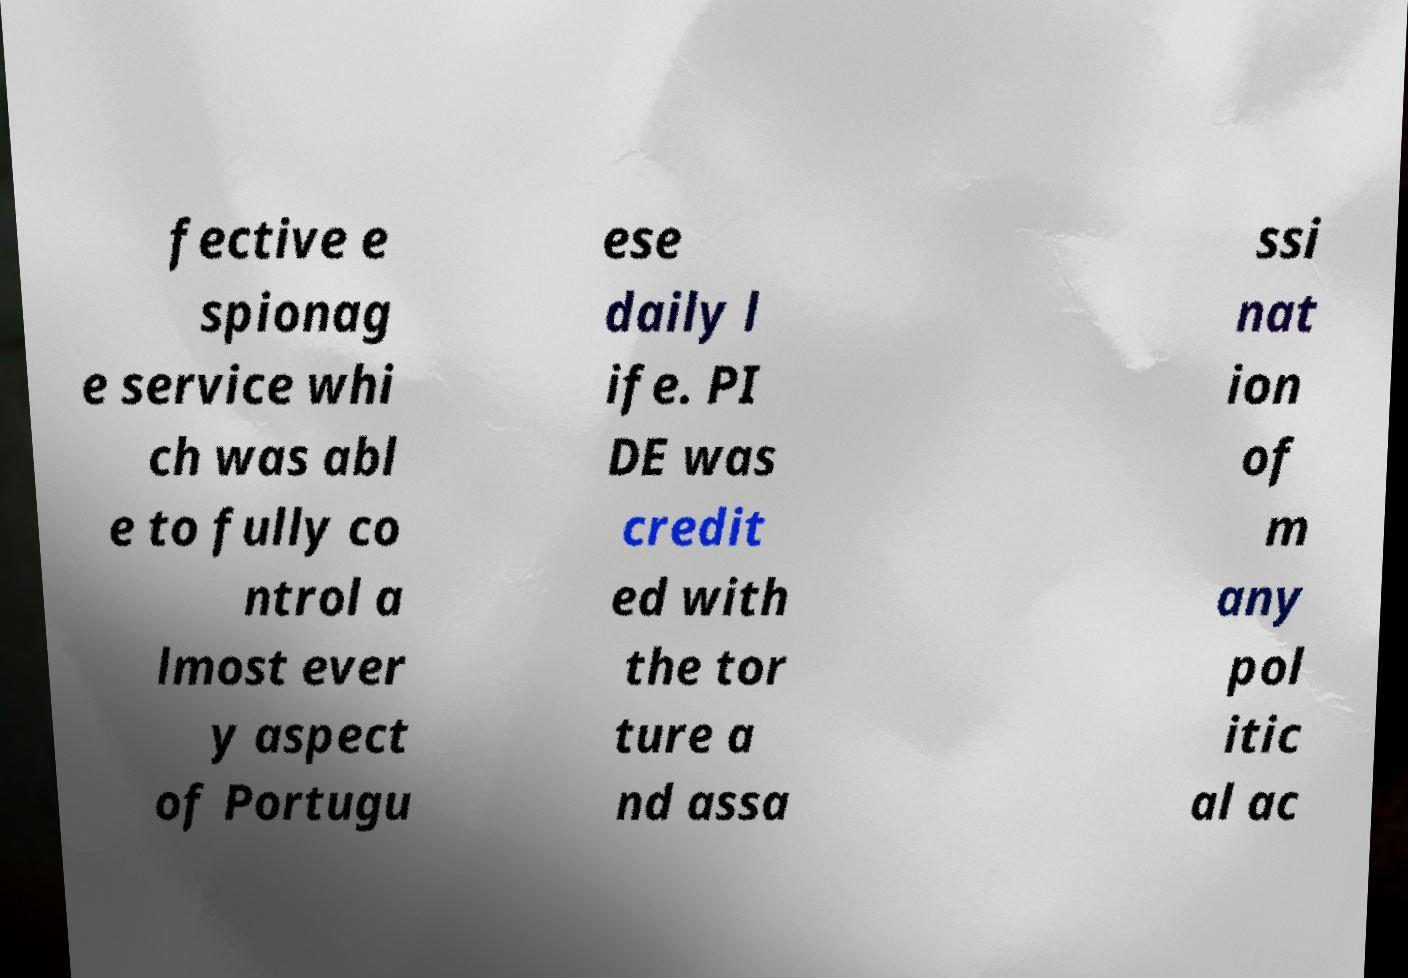Could you assist in decoding the text presented in this image and type it out clearly? fective e spionag e service whi ch was abl e to fully co ntrol a lmost ever y aspect of Portugu ese daily l ife. PI DE was credit ed with the tor ture a nd assa ssi nat ion of m any pol itic al ac 